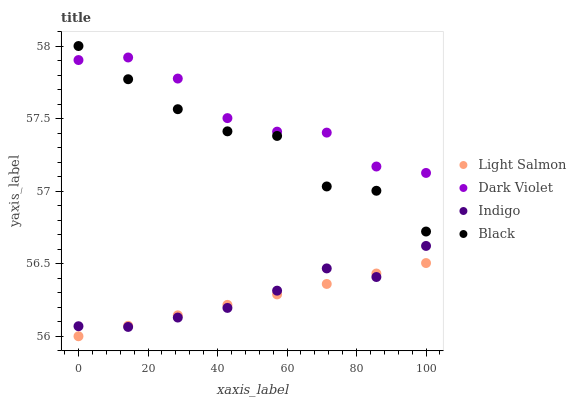Does Light Salmon have the minimum area under the curve?
Answer yes or no. Yes. Does Dark Violet have the maximum area under the curve?
Answer yes or no. Yes. Does Indigo have the minimum area under the curve?
Answer yes or no. No. Does Indigo have the maximum area under the curve?
Answer yes or no. No. Is Light Salmon the smoothest?
Answer yes or no. Yes. Is Black the roughest?
Answer yes or no. Yes. Is Indigo the smoothest?
Answer yes or no. No. Is Indigo the roughest?
Answer yes or no. No. Does Light Salmon have the lowest value?
Answer yes or no. Yes. Does Indigo have the lowest value?
Answer yes or no. No. Does Black have the highest value?
Answer yes or no. Yes. Does Indigo have the highest value?
Answer yes or no. No. Is Indigo less than Black?
Answer yes or no. Yes. Is Black greater than Light Salmon?
Answer yes or no. Yes. Does Indigo intersect Light Salmon?
Answer yes or no. Yes. Is Indigo less than Light Salmon?
Answer yes or no. No. Is Indigo greater than Light Salmon?
Answer yes or no. No. Does Indigo intersect Black?
Answer yes or no. No. 